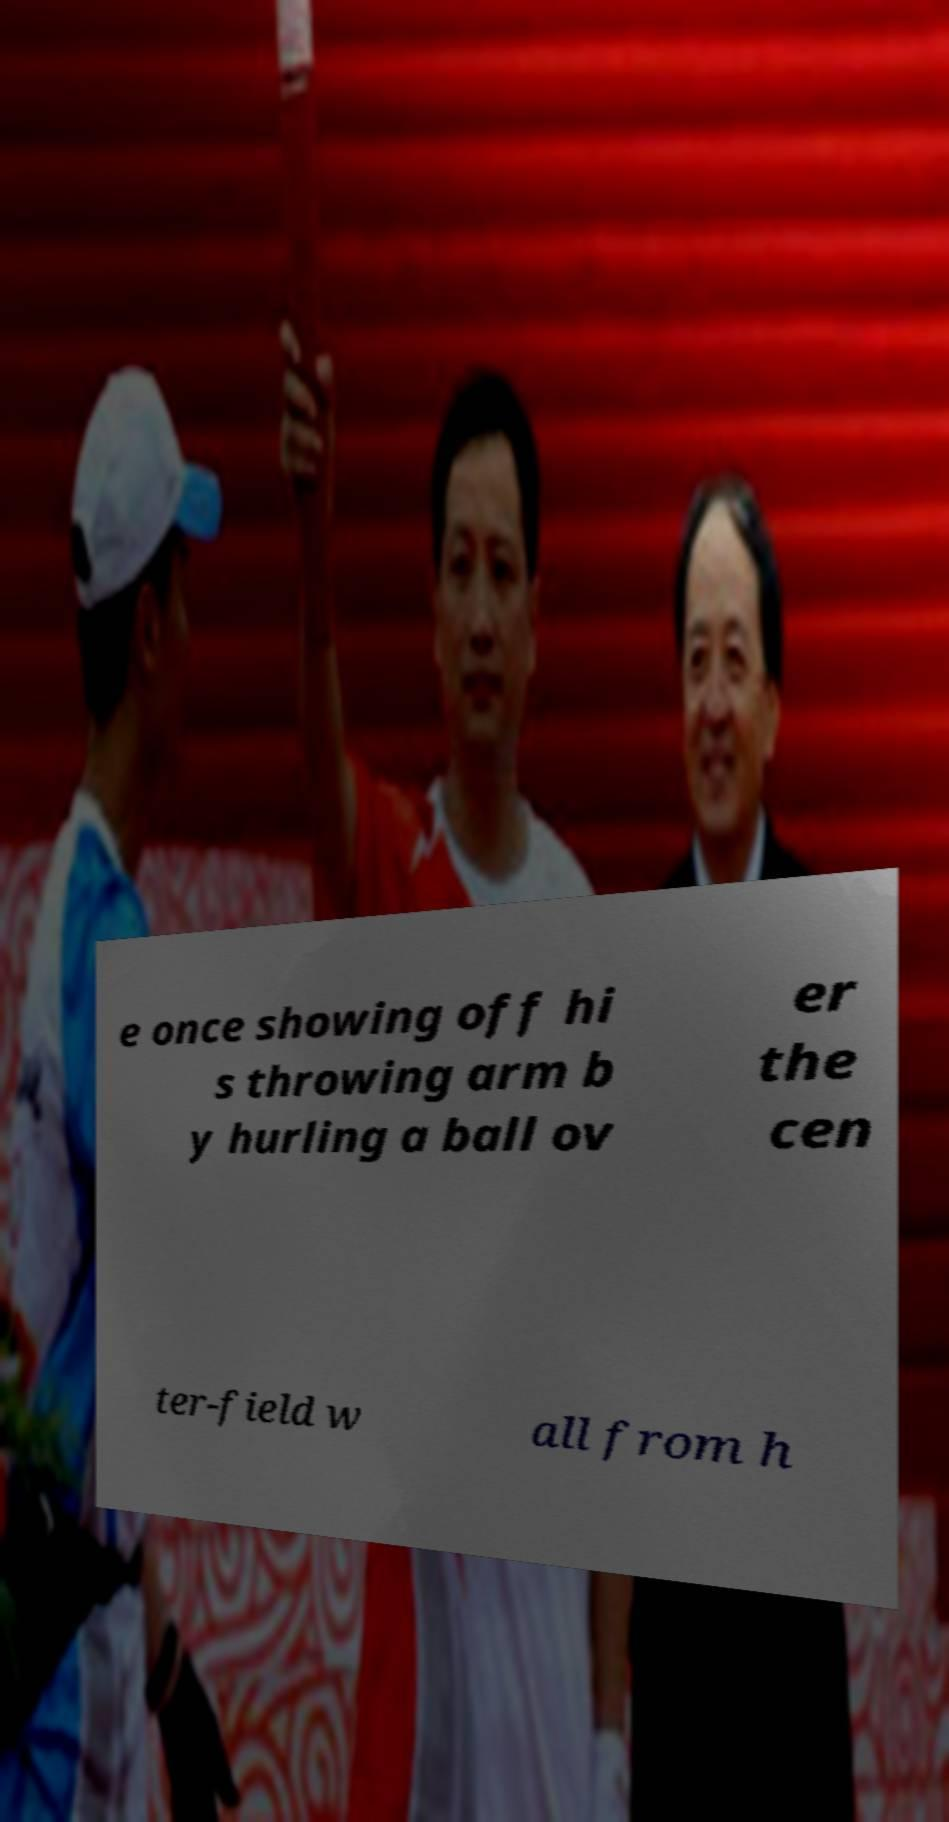Please identify and transcribe the text found in this image. e once showing off hi s throwing arm b y hurling a ball ov er the cen ter-field w all from h 